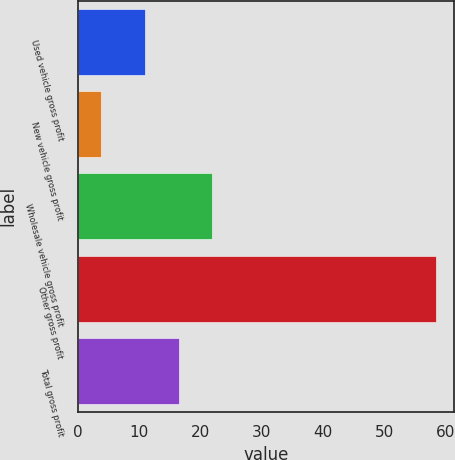Convert chart to OTSL. <chart><loc_0><loc_0><loc_500><loc_500><bar_chart><fcel>Used vehicle gross profit<fcel>New vehicle gross profit<fcel>Wholesale vehicle gross profit<fcel>Other gross profit<fcel>Total gross profit<nl><fcel>11<fcel>3.9<fcel>21.92<fcel>58.5<fcel>16.46<nl></chart> 